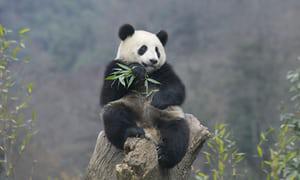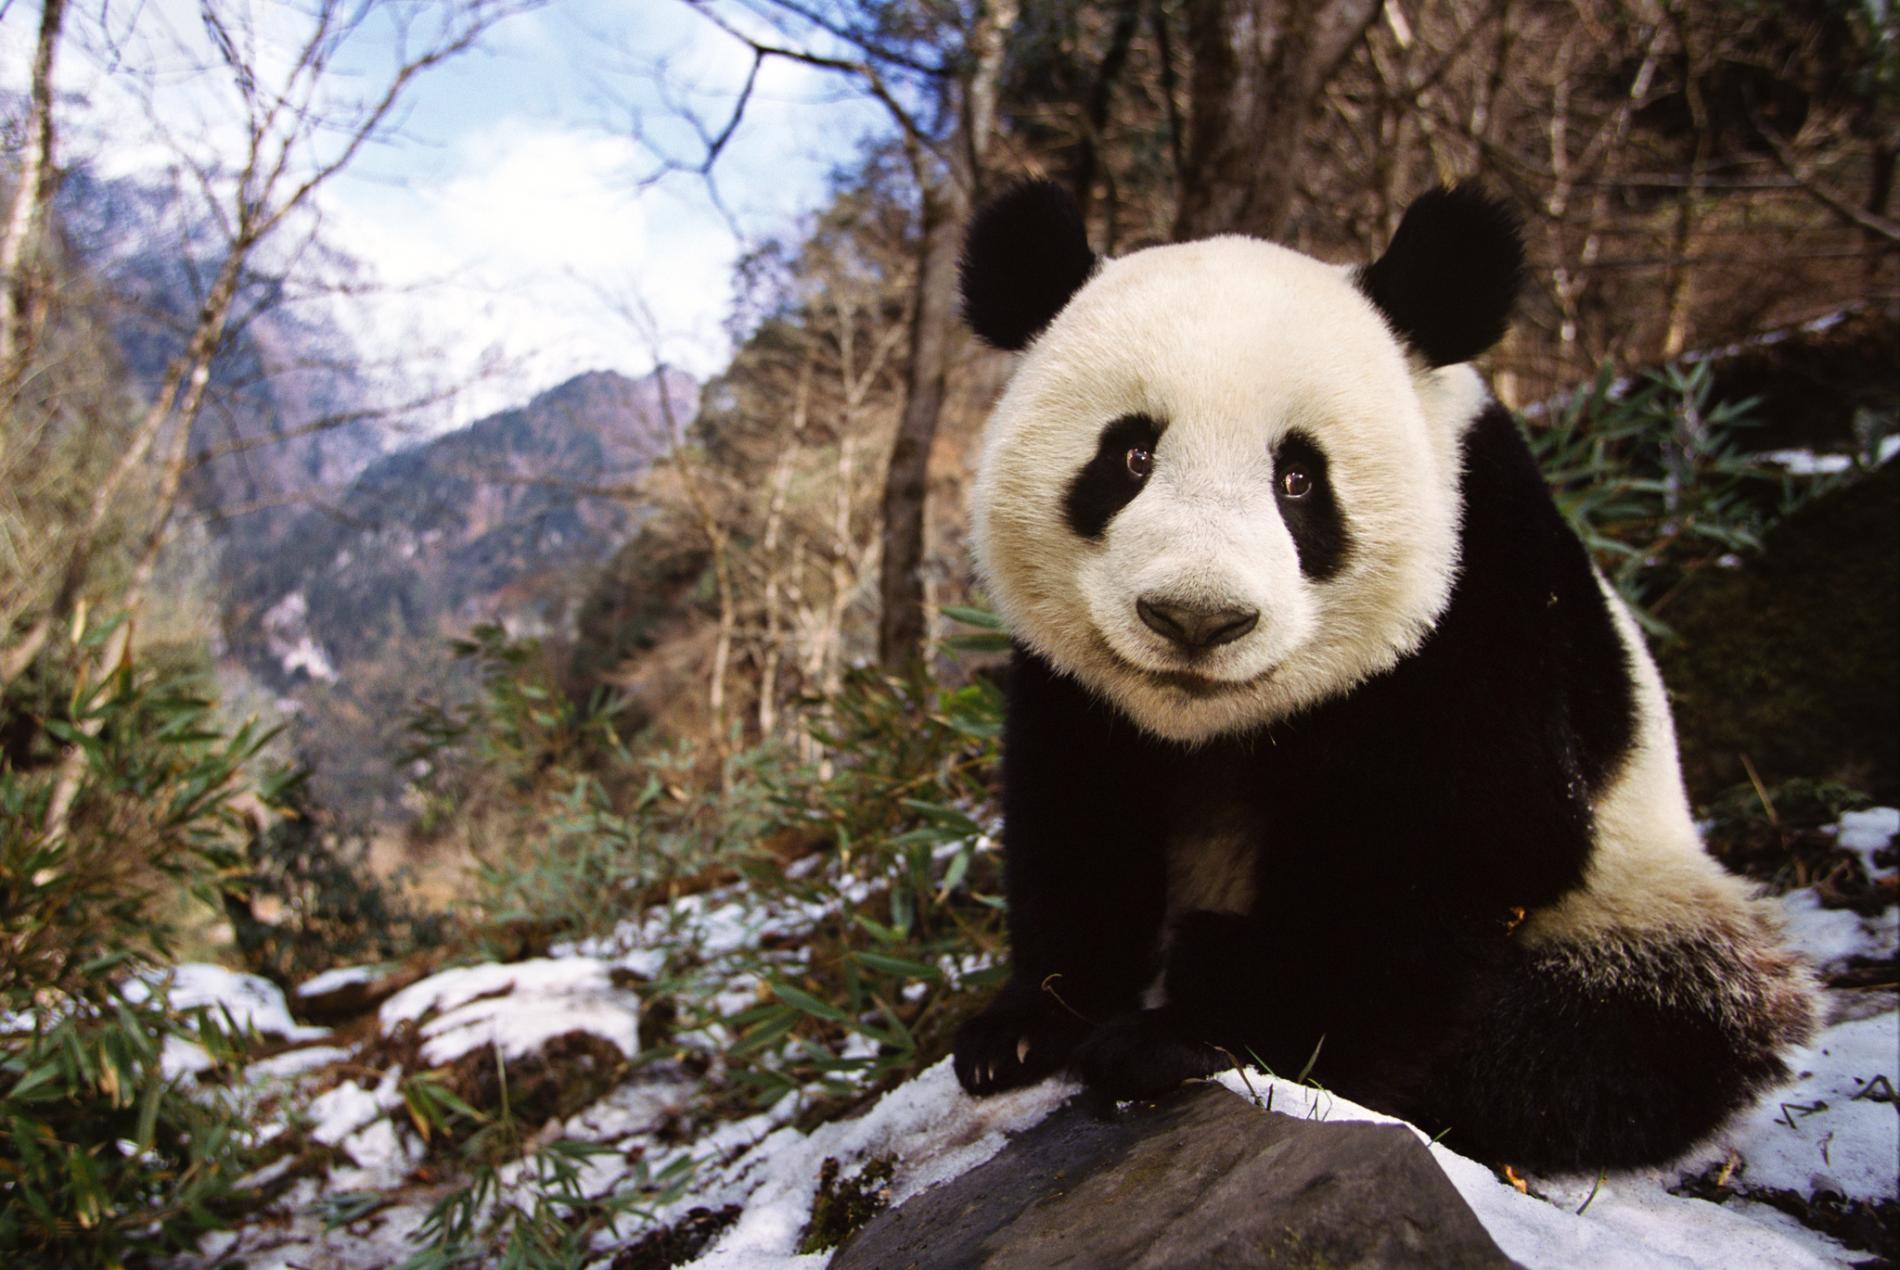The first image is the image on the left, the second image is the image on the right. Examine the images to the left and right. Is the description "A giant panda is frolicking outside." accurate? Answer yes or no. Yes. The first image is the image on the left, the second image is the image on the right. Evaluate the accuracy of this statement regarding the images: "The panda in the image to the left is alone.". Is it true? Answer yes or no. Yes. 